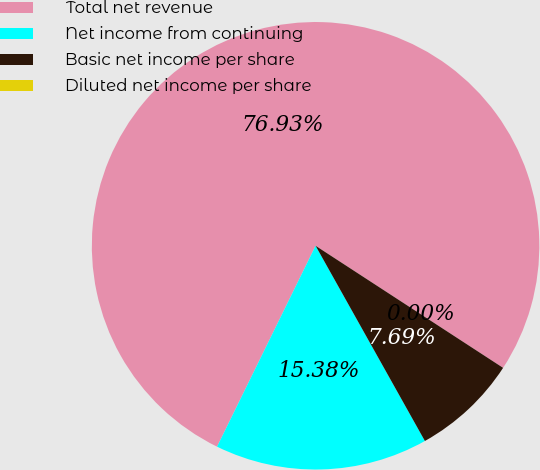Convert chart to OTSL. <chart><loc_0><loc_0><loc_500><loc_500><pie_chart><fcel>Total net revenue<fcel>Net income from continuing<fcel>Basic net income per share<fcel>Diluted net income per share<nl><fcel>76.92%<fcel>15.38%<fcel>7.69%<fcel>0.0%<nl></chart> 